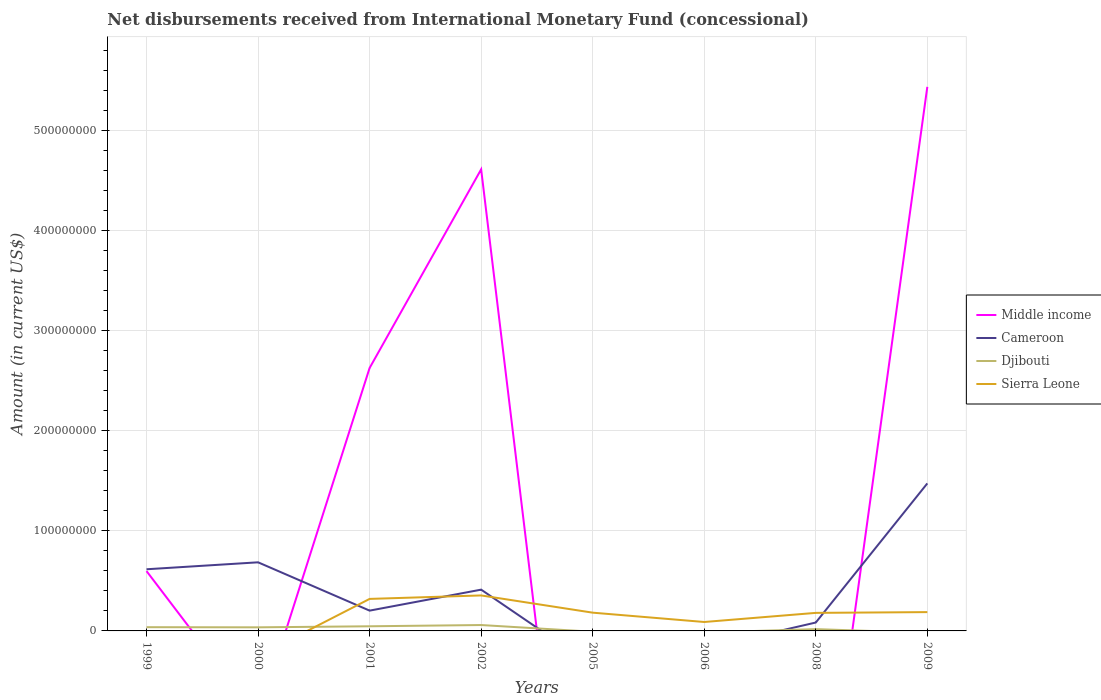How many different coloured lines are there?
Offer a terse response. 4. Does the line corresponding to Cameroon intersect with the line corresponding to Middle income?
Make the answer very short. Yes. Is the number of lines equal to the number of legend labels?
Ensure brevity in your answer.  No. What is the total amount of disbursements received from International Monetary Fund in Sierra Leone in the graph?
Provide a short and direct response. 2.17e+05. What is the difference between the highest and the second highest amount of disbursements received from International Monetary Fund in Middle income?
Give a very brief answer. 5.43e+08. What is the difference between the highest and the lowest amount of disbursements received from International Monetary Fund in Sierra Leone?
Make the answer very short. 5. Is the amount of disbursements received from International Monetary Fund in Cameroon strictly greater than the amount of disbursements received from International Monetary Fund in Djibouti over the years?
Your answer should be very brief. No. Are the values on the major ticks of Y-axis written in scientific E-notation?
Your answer should be compact. No. How many legend labels are there?
Your answer should be very brief. 4. How are the legend labels stacked?
Your response must be concise. Vertical. What is the title of the graph?
Your response must be concise. Net disbursements received from International Monetary Fund (concessional). Does "Cabo Verde" appear as one of the legend labels in the graph?
Your answer should be compact. No. What is the label or title of the Y-axis?
Your response must be concise. Amount (in current US$). What is the Amount (in current US$) of Middle income in 1999?
Keep it short and to the point. 5.98e+07. What is the Amount (in current US$) in Cameroon in 1999?
Offer a terse response. 6.16e+07. What is the Amount (in current US$) of Djibouti in 1999?
Your answer should be very brief. 3.73e+06. What is the Amount (in current US$) in Sierra Leone in 1999?
Your answer should be very brief. 0. What is the Amount (in current US$) in Middle income in 2000?
Give a very brief answer. 0. What is the Amount (in current US$) of Cameroon in 2000?
Offer a terse response. 6.85e+07. What is the Amount (in current US$) of Djibouti in 2000?
Offer a very short reply. 3.60e+06. What is the Amount (in current US$) of Sierra Leone in 2000?
Provide a succinct answer. 0. What is the Amount (in current US$) in Middle income in 2001?
Your response must be concise. 2.63e+08. What is the Amount (in current US$) of Cameroon in 2001?
Ensure brevity in your answer.  2.03e+07. What is the Amount (in current US$) of Djibouti in 2001?
Offer a terse response. 4.63e+06. What is the Amount (in current US$) in Sierra Leone in 2001?
Offer a very short reply. 3.20e+07. What is the Amount (in current US$) in Middle income in 2002?
Your answer should be compact. 4.61e+08. What is the Amount (in current US$) in Cameroon in 2002?
Ensure brevity in your answer.  4.12e+07. What is the Amount (in current US$) of Djibouti in 2002?
Make the answer very short. 5.88e+06. What is the Amount (in current US$) in Sierra Leone in 2002?
Provide a short and direct response. 3.54e+07. What is the Amount (in current US$) in Sierra Leone in 2005?
Give a very brief answer. 1.82e+07. What is the Amount (in current US$) in Middle income in 2006?
Offer a very short reply. 0. What is the Amount (in current US$) in Cameroon in 2006?
Ensure brevity in your answer.  0. What is the Amount (in current US$) in Djibouti in 2006?
Provide a short and direct response. 0. What is the Amount (in current US$) in Sierra Leone in 2006?
Make the answer very short. 8.92e+06. What is the Amount (in current US$) of Cameroon in 2008?
Provide a succinct answer. 8.38e+06. What is the Amount (in current US$) in Djibouti in 2008?
Offer a very short reply. 1.80e+06. What is the Amount (in current US$) of Sierra Leone in 2008?
Give a very brief answer. 1.80e+07. What is the Amount (in current US$) in Middle income in 2009?
Your response must be concise. 5.43e+08. What is the Amount (in current US$) of Cameroon in 2009?
Keep it short and to the point. 1.47e+08. What is the Amount (in current US$) of Djibouti in 2009?
Keep it short and to the point. 0. What is the Amount (in current US$) of Sierra Leone in 2009?
Offer a terse response. 1.88e+07. Across all years, what is the maximum Amount (in current US$) in Middle income?
Give a very brief answer. 5.43e+08. Across all years, what is the maximum Amount (in current US$) in Cameroon?
Ensure brevity in your answer.  1.47e+08. Across all years, what is the maximum Amount (in current US$) in Djibouti?
Make the answer very short. 5.88e+06. Across all years, what is the maximum Amount (in current US$) in Sierra Leone?
Your answer should be compact. 3.54e+07. What is the total Amount (in current US$) of Middle income in the graph?
Offer a very short reply. 1.33e+09. What is the total Amount (in current US$) in Cameroon in the graph?
Offer a terse response. 3.47e+08. What is the total Amount (in current US$) of Djibouti in the graph?
Your answer should be compact. 1.96e+07. What is the total Amount (in current US$) of Sierra Leone in the graph?
Keep it short and to the point. 1.31e+08. What is the difference between the Amount (in current US$) in Cameroon in 1999 and that in 2000?
Offer a terse response. -6.95e+06. What is the difference between the Amount (in current US$) of Djibouti in 1999 and that in 2000?
Offer a terse response. 1.32e+05. What is the difference between the Amount (in current US$) in Middle income in 1999 and that in 2001?
Offer a very short reply. -2.03e+08. What is the difference between the Amount (in current US$) in Cameroon in 1999 and that in 2001?
Ensure brevity in your answer.  4.13e+07. What is the difference between the Amount (in current US$) in Djibouti in 1999 and that in 2001?
Keep it short and to the point. -9.00e+05. What is the difference between the Amount (in current US$) of Middle income in 1999 and that in 2002?
Your answer should be very brief. -4.01e+08. What is the difference between the Amount (in current US$) of Cameroon in 1999 and that in 2002?
Make the answer very short. 2.03e+07. What is the difference between the Amount (in current US$) in Djibouti in 1999 and that in 2002?
Ensure brevity in your answer.  -2.16e+06. What is the difference between the Amount (in current US$) in Cameroon in 1999 and that in 2008?
Your answer should be compact. 5.32e+07. What is the difference between the Amount (in current US$) of Djibouti in 1999 and that in 2008?
Provide a short and direct response. 1.93e+06. What is the difference between the Amount (in current US$) of Middle income in 1999 and that in 2009?
Keep it short and to the point. -4.84e+08. What is the difference between the Amount (in current US$) in Cameroon in 1999 and that in 2009?
Provide a succinct answer. -8.58e+07. What is the difference between the Amount (in current US$) of Cameroon in 2000 and that in 2001?
Ensure brevity in your answer.  4.83e+07. What is the difference between the Amount (in current US$) in Djibouti in 2000 and that in 2001?
Your answer should be very brief. -1.03e+06. What is the difference between the Amount (in current US$) of Cameroon in 2000 and that in 2002?
Provide a short and direct response. 2.73e+07. What is the difference between the Amount (in current US$) in Djibouti in 2000 and that in 2002?
Give a very brief answer. -2.29e+06. What is the difference between the Amount (in current US$) of Cameroon in 2000 and that in 2008?
Provide a succinct answer. 6.01e+07. What is the difference between the Amount (in current US$) in Djibouti in 2000 and that in 2008?
Your answer should be compact. 1.80e+06. What is the difference between the Amount (in current US$) of Cameroon in 2000 and that in 2009?
Ensure brevity in your answer.  -7.88e+07. What is the difference between the Amount (in current US$) in Middle income in 2001 and that in 2002?
Ensure brevity in your answer.  -1.98e+08. What is the difference between the Amount (in current US$) of Cameroon in 2001 and that in 2002?
Your answer should be very brief. -2.10e+07. What is the difference between the Amount (in current US$) in Djibouti in 2001 and that in 2002?
Give a very brief answer. -1.26e+06. What is the difference between the Amount (in current US$) in Sierra Leone in 2001 and that in 2002?
Provide a succinct answer. -3.47e+06. What is the difference between the Amount (in current US$) of Sierra Leone in 2001 and that in 2005?
Give a very brief answer. 1.37e+07. What is the difference between the Amount (in current US$) in Sierra Leone in 2001 and that in 2006?
Offer a very short reply. 2.30e+07. What is the difference between the Amount (in current US$) in Cameroon in 2001 and that in 2008?
Offer a terse response. 1.19e+07. What is the difference between the Amount (in current US$) in Djibouti in 2001 and that in 2008?
Provide a short and direct response. 2.83e+06. What is the difference between the Amount (in current US$) of Sierra Leone in 2001 and that in 2008?
Your answer should be very brief. 1.39e+07. What is the difference between the Amount (in current US$) in Middle income in 2001 and that in 2009?
Offer a terse response. -2.81e+08. What is the difference between the Amount (in current US$) in Cameroon in 2001 and that in 2009?
Provide a succinct answer. -1.27e+08. What is the difference between the Amount (in current US$) in Sierra Leone in 2001 and that in 2009?
Offer a terse response. 1.32e+07. What is the difference between the Amount (in current US$) of Sierra Leone in 2002 and that in 2005?
Your answer should be very brief. 1.72e+07. What is the difference between the Amount (in current US$) in Sierra Leone in 2002 and that in 2006?
Make the answer very short. 2.65e+07. What is the difference between the Amount (in current US$) in Cameroon in 2002 and that in 2008?
Your answer should be very brief. 3.29e+07. What is the difference between the Amount (in current US$) in Djibouti in 2002 and that in 2008?
Keep it short and to the point. 4.08e+06. What is the difference between the Amount (in current US$) of Sierra Leone in 2002 and that in 2008?
Give a very brief answer. 1.74e+07. What is the difference between the Amount (in current US$) of Middle income in 2002 and that in 2009?
Your response must be concise. -8.24e+07. What is the difference between the Amount (in current US$) of Cameroon in 2002 and that in 2009?
Offer a terse response. -1.06e+08. What is the difference between the Amount (in current US$) in Sierra Leone in 2002 and that in 2009?
Give a very brief answer. 1.66e+07. What is the difference between the Amount (in current US$) of Sierra Leone in 2005 and that in 2006?
Give a very brief answer. 9.32e+06. What is the difference between the Amount (in current US$) of Sierra Leone in 2005 and that in 2008?
Your response must be concise. 2.17e+05. What is the difference between the Amount (in current US$) of Sierra Leone in 2005 and that in 2009?
Your answer should be very brief. -5.57e+05. What is the difference between the Amount (in current US$) in Sierra Leone in 2006 and that in 2008?
Offer a terse response. -9.10e+06. What is the difference between the Amount (in current US$) in Sierra Leone in 2006 and that in 2009?
Your answer should be very brief. -9.88e+06. What is the difference between the Amount (in current US$) of Cameroon in 2008 and that in 2009?
Offer a very short reply. -1.39e+08. What is the difference between the Amount (in current US$) in Sierra Leone in 2008 and that in 2009?
Your answer should be compact. -7.74e+05. What is the difference between the Amount (in current US$) of Middle income in 1999 and the Amount (in current US$) of Cameroon in 2000?
Ensure brevity in your answer.  -8.77e+06. What is the difference between the Amount (in current US$) of Middle income in 1999 and the Amount (in current US$) of Djibouti in 2000?
Offer a very short reply. 5.62e+07. What is the difference between the Amount (in current US$) in Cameroon in 1999 and the Amount (in current US$) in Djibouti in 2000?
Your answer should be very brief. 5.80e+07. What is the difference between the Amount (in current US$) of Middle income in 1999 and the Amount (in current US$) of Cameroon in 2001?
Provide a succinct answer. 3.95e+07. What is the difference between the Amount (in current US$) of Middle income in 1999 and the Amount (in current US$) of Djibouti in 2001?
Give a very brief answer. 5.51e+07. What is the difference between the Amount (in current US$) in Middle income in 1999 and the Amount (in current US$) in Sierra Leone in 2001?
Make the answer very short. 2.78e+07. What is the difference between the Amount (in current US$) in Cameroon in 1999 and the Amount (in current US$) in Djibouti in 2001?
Make the answer very short. 5.69e+07. What is the difference between the Amount (in current US$) in Cameroon in 1999 and the Amount (in current US$) in Sierra Leone in 2001?
Make the answer very short. 2.96e+07. What is the difference between the Amount (in current US$) of Djibouti in 1999 and the Amount (in current US$) of Sierra Leone in 2001?
Offer a terse response. -2.82e+07. What is the difference between the Amount (in current US$) of Middle income in 1999 and the Amount (in current US$) of Cameroon in 2002?
Give a very brief answer. 1.85e+07. What is the difference between the Amount (in current US$) in Middle income in 1999 and the Amount (in current US$) in Djibouti in 2002?
Keep it short and to the point. 5.39e+07. What is the difference between the Amount (in current US$) in Middle income in 1999 and the Amount (in current US$) in Sierra Leone in 2002?
Keep it short and to the point. 2.43e+07. What is the difference between the Amount (in current US$) in Cameroon in 1999 and the Amount (in current US$) in Djibouti in 2002?
Your answer should be compact. 5.57e+07. What is the difference between the Amount (in current US$) in Cameroon in 1999 and the Amount (in current US$) in Sierra Leone in 2002?
Your answer should be very brief. 2.61e+07. What is the difference between the Amount (in current US$) in Djibouti in 1999 and the Amount (in current US$) in Sierra Leone in 2002?
Your answer should be compact. -3.17e+07. What is the difference between the Amount (in current US$) in Middle income in 1999 and the Amount (in current US$) in Sierra Leone in 2005?
Provide a short and direct response. 4.15e+07. What is the difference between the Amount (in current US$) of Cameroon in 1999 and the Amount (in current US$) of Sierra Leone in 2005?
Provide a succinct answer. 4.33e+07. What is the difference between the Amount (in current US$) of Djibouti in 1999 and the Amount (in current US$) of Sierra Leone in 2005?
Provide a short and direct response. -1.45e+07. What is the difference between the Amount (in current US$) in Middle income in 1999 and the Amount (in current US$) in Sierra Leone in 2006?
Offer a very short reply. 5.08e+07. What is the difference between the Amount (in current US$) of Cameroon in 1999 and the Amount (in current US$) of Sierra Leone in 2006?
Ensure brevity in your answer.  5.27e+07. What is the difference between the Amount (in current US$) of Djibouti in 1999 and the Amount (in current US$) of Sierra Leone in 2006?
Provide a succinct answer. -5.19e+06. What is the difference between the Amount (in current US$) in Middle income in 1999 and the Amount (in current US$) in Cameroon in 2008?
Offer a terse response. 5.14e+07. What is the difference between the Amount (in current US$) in Middle income in 1999 and the Amount (in current US$) in Djibouti in 2008?
Ensure brevity in your answer.  5.80e+07. What is the difference between the Amount (in current US$) in Middle income in 1999 and the Amount (in current US$) in Sierra Leone in 2008?
Your answer should be compact. 4.17e+07. What is the difference between the Amount (in current US$) of Cameroon in 1999 and the Amount (in current US$) of Djibouti in 2008?
Keep it short and to the point. 5.98e+07. What is the difference between the Amount (in current US$) in Cameroon in 1999 and the Amount (in current US$) in Sierra Leone in 2008?
Offer a very short reply. 4.36e+07. What is the difference between the Amount (in current US$) in Djibouti in 1999 and the Amount (in current US$) in Sierra Leone in 2008?
Provide a succinct answer. -1.43e+07. What is the difference between the Amount (in current US$) of Middle income in 1999 and the Amount (in current US$) of Cameroon in 2009?
Keep it short and to the point. -8.76e+07. What is the difference between the Amount (in current US$) in Middle income in 1999 and the Amount (in current US$) in Sierra Leone in 2009?
Provide a succinct answer. 4.10e+07. What is the difference between the Amount (in current US$) in Cameroon in 1999 and the Amount (in current US$) in Sierra Leone in 2009?
Give a very brief answer. 4.28e+07. What is the difference between the Amount (in current US$) of Djibouti in 1999 and the Amount (in current US$) of Sierra Leone in 2009?
Your answer should be compact. -1.51e+07. What is the difference between the Amount (in current US$) in Cameroon in 2000 and the Amount (in current US$) in Djibouti in 2001?
Your response must be concise. 6.39e+07. What is the difference between the Amount (in current US$) in Cameroon in 2000 and the Amount (in current US$) in Sierra Leone in 2001?
Provide a short and direct response. 3.66e+07. What is the difference between the Amount (in current US$) of Djibouti in 2000 and the Amount (in current US$) of Sierra Leone in 2001?
Provide a short and direct response. -2.84e+07. What is the difference between the Amount (in current US$) of Cameroon in 2000 and the Amount (in current US$) of Djibouti in 2002?
Offer a very short reply. 6.26e+07. What is the difference between the Amount (in current US$) of Cameroon in 2000 and the Amount (in current US$) of Sierra Leone in 2002?
Make the answer very short. 3.31e+07. What is the difference between the Amount (in current US$) of Djibouti in 2000 and the Amount (in current US$) of Sierra Leone in 2002?
Give a very brief answer. -3.18e+07. What is the difference between the Amount (in current US$) in Cameroon in 2000 and the Amount (in current US$) in Sierra Leone in 2005?
Your response must be concise. 5.03e+07. What is the difference between the Amount (in current US$) in Djibouti in 2000 and the Amount (in current US$) in Sierra Leone in 2005?
Provide a short and direct response. -1.46e+07. What is the difference between the Amount (in current US$) of Cameroon in 2000 and the Amount (in current US$) of Sierra Leone in 2006?
Offer a terse response. 5.96e+07. What is the difference between the Amount (in current US$) of Djibouti in 2000 and the Amount (in current US$) of Sierra Leone in 2006?
Your response must be concise. -5.32e+06. What is the difference between the Amount (in current US$) of Cameroon in 2000 and the Amount (in current US$) of Djibouti in 2008?
Give a very brief answer. 6.67e+07. What is the difference between the Amount (in current US$) in Cameroon in 2000 and the Amount (in current US$) in Sierra Leone in 2008?
Ensure brevity in your answer.  5.05e+07. What is the difference between the Amount (in current US$) of Djibouti in 2000 and the Amount (in current US$) of Sierra Leone in 2008?
Your answer should be very brief. -1.44e+07. What is the difference between the Amount (in current US$) of Cameroon in 2000 and the Amount (in current US$) of Sierra Leone in 2009?
Provide a short and direct response. 4.97e+07. What is the difference between the Amount (in current US$) of Djibouti in 2000 and the Amount (in current US$) of Sierra Leone in 2009?
Your response must be concise. -1.52e+07. What is the difference between the Amount (in current US$) of Middle income in 2001 and the Amount (in current US$) of Cameroon in 2002?
Provide a short and direct response. 2.21e+08. What is the difference between the Amount (in current US$) of Middle income in 2001 and the Amount (in current US$) of Djibouti in 2002?
Your answer should be compact. 2.57e+08. What is the difference between the Amount (in current US$) in Middle income in 2001 and the Amount (in current US$) in Sierra Leone in 2002?
Provide a short and direct response. 2.27e+08. What is the difference between the Amount (in current US$) of Cameroon in 2001 and the Amount (in current US$) of Djibouti in 2002?
Provide a short and direct response. 1.44e+07. What is the difference between the Amount (in current US$) of Cameroon in 2001 and the Amount (in current US$) of Sierra Leone in 2002?
Your response must be concise. -1.52e+07. What is the difference between the Amount (in current US$) in Djibouti in 2001 and the Amount (in current US$) in Sierra Leone in 2002?
Ensure brevity in your answer.  -3.08e+07. What is the difference between the Amount (in current US$) of Middle income in 2001 and the Amount (in current US$) of Sierra Leone in 2005?
Your response must be concise. 2.44e+08. What is the difference between the Amount (in current US$) of Cameroon in 2001 and the Amount (in current US$) of Sierra Leone in 2005?
Keep it short and to the point. 2.03e+06. What is the difference between the Amount (in current US$) in Djibouti in 2001 and the Amount (in current US$) in Sierra Leone in 2005?
Ensure brevity in your answer.  -1.36e+07. What is the difference between the Amount (in current US$) of Middle income in 2001 and the Amount (in current US$) of Sierra Leone in 2006?
Ensure brevity in your answer.  2.54e+08. What is the difference between the Amount (in current US$) in Cameroon in 2001 and the Amount (in current US$) in Sierra Leone in 2006?
Your response must be concise. 1.13e+07. What is the difference between the Amount (in current US$) in Djibouti in 2001 and the Amount (in current US$) in Sierra Leone in 2006?
Your response must be concise. -4.29e+06. What is the difference between the Amount (in current US$) in Middle income in 2001 and the Amount (in current US$) in Cameroon in 2008?
Provide a succinct answer. 2.54e+08. What is the difference between the Amount (in current US$) in Middle income in 2001 and the Amount (in current US$) in Djibouti in 2008?
Your answer should be very brief. 2.61e+08. What is the difference between the Amount (in current US$) of Middle income in 2001 and the Amount (in current US$) of Sierra Leone in 2008?
Your answer should be compact. 2.45e+08. What is the difference between the Amount (in current US$) in Cameroon in 2001 and the Amount (in current US$) in Djibouti in 2008?
Your answer should be compact. 1.85e+07. What is the difference between the Amount (in current US$) in Cameroon in 2001 and the Amount (in current US$) in Sierra Leone in 2008?
Your response must be concise. 2.25e+06. What is the difference between the Amount (in current US$) of Djibouti in 2001 and the Amount (in current US$) of Sierra Leone in 2008?
Provide a short and direct response. -1.34e+07. What is the difference between the Amount (in current US$) in Middle income in 2001 and the Amount (in current US$) in Cameroon in 2009?
Your answer should be very brief. 1.15e+08. What is the difference between the Amount (in current US$) in Middle income in 2001 and the Amount (in current US$) in Sierra Leone in 2009?
Offer a very short reply. 2.44e+08. What is the difference between the Amount (in current US$) in Cameroon in 2001 and the Amount (in current US$) in Sierra Leone in 2009?
Your answer should be very brief. 1.47e+06. What is the difference between the Amount (in current US$) in Djibouti in 2001 and the Amount (in current US$) in Sierra Leone in 2009?
Provide a succinct answer. -1.42e+07. What is the difference between the Amount (in current US$) of Middle income in 2002 and the Amount (in current US$) of Sierra Leone in 2005?
Give a very brief answer. 4.43e+08. What is the difference between the Amount (in current US$) in Cameroon in 2002 and the Amount (in current US$) in Sierra Leone in 2005?
Keep it short and to the point. 2.30e+07. What is the difference between the Amount (in current US$) in Djibouti in 2002 and the Amount (in current US$) in Sierra Leone in 2005?
Your response must be concise. -1.24e+07. What is the difference between the Amount (in current US$) in Middle income in 2002 and the Amount (in current US$) in Sierra Leone in 2006?
Your answer should be very brief. 4.52e+08. What is the difference between the Amount (in current US$) of Cameroon in 2002 and the Amount (in current US$) of Sierra Leone in 2006?
Ensure brevity in your answer.  3.23e+07. What is the difference between the Amount (in current US$) of Djibouti in 2002 and the Amount (in current US$) of Sierra Leone in 2006?
Offer a terse response. -3.04e+06. What is the difference between the Amount (in current US$) of Middle income in 2002 and the Amount (in current US$) of Cameroon in 2008?
Give a very brief answer. 4.53e+08. What is the difference between the Amount (in current US$) in Middle income in 2002 and the Amount (in current US$) in Djibouti in 2008?
Offer a terse response. 4.59e+08. What is the difference between the Amount (in current US$) in Middle income in 2002 and the Amount (in current US$) in Sierra Leone in 2008?
Your response must be concise. 4.43e+08. What is the difference between the Amount (in current US$) of Cameroon in 2002 and the Amount (in current US$) of Djibouti in 2008?
Give a very brief answer. 3.94e+07. What is the difference between the Amount (in current US$) of Cameroon in 2002 and the Amount (in current US$) of Sierra Leone in 2008?
Your answer should be compact. 2.32e+07. What is the difference between the Amount (in current US$) in Djibouti in 2002 and the Amount (in current US$) in Sierra Leone in 2008?
Keep it short and to the point. -1.21e+07. What is the difference between the Amount (in current US$) of Middle income in 2002 and the Amount (in current US$) of Cameroon in 2009?
Your answer should be compact. 3.14e+08. What is the difference between the Amount (in current US$) of Middle income in 2002 and the Amount (in current US$) of Sierra Leone in 2009?
Ensure brevity in your answer.  4.42e+08. What is the difference between the Amount (in current US$) in Cameroon in 2002 and the Amount (in current US$) in Sierra Leone in 2009?
Keep it short and to the point. 2.24e+07. What is the difference between the Amount (in current US$) in Djibouti in 2002 and the Amount (in current US$) in Sierra Leone in 2009?
Provide a succinct answer. -1.29e+07. What is the difference between the Amount (in current US$) in Cameroon in 2008 and the Amount (in current US$) in Sierra Leone in 2009?
Your answer should be compact. -1.04e+07. What is the difference between the Amount (in current US$) in Djibouti in 2008 and the Amount (in current US$) in Sierra Leone in 2009?
Ensure brevity in your answer.  -1.70e+07. What is the average Amount (in current US$) in Middle income per year?
Your response must be concise. 1.66e+08. What is the average Amount (in current US$) in Cameroon per year?
Offer a terse response. 4.34e+07. What is the average Amount (in current US$) in Djibouti per year?
Your answer should be compact. 2.45e+06. What is the average Amount (in current US$) of Sierra Leone per year?
Keep it short and to the point. 1.64e+07. In the year 1999, what is the difference between the Amount (in current US$) of Middle income and Amount (in current US$) of Cameroon?
Provide a succinct answer. -1.82e+06. In the year 1999, what is the difference between the Amount (in current US$) in Middle income and Amount (in current US$) in Djibouti?
Offer a very short reply. 5.60e+07. In the year 1999, what is the difference between the Amount (in current US$) of Cameroon and Amount (in current US$) of Djibouti?
Your response must be concise. 5.78e+07. In the year 2000, what is the difference between the Amount (in current US$) of Cameroon and Amount (in current US$) of Djibouti?
Provide a short and direct response. 6.49e+07. In the year 2001, what is the difference between the Amount (in current US$) of Middle income and Amount (in current US$) of Cameroon?
Provide a succinct answer. 2.42e+08. In the year 2001, what is the difference between the Amount (in current US$) in Middle income and Amount (in current US$) in Djibouti?
Ensure brevity in your answer.  2.58e+08. In the year 2001, what is the difference between the Amount (in current US$) in Middle income and Amount (in current US$) in Sierra Leone?
Give a very brief answer. 2.31e+08. In the year 2001, what is the difference between the Amount (in current US$) in Cameroon and Amount (in current US$) in Djibouti?
Your answer should be compact. 1.56e+07. In the year 2001, what is the difference between the Amount (in current US$) of Cameroon and Amount (in current US$) of Sierra Leone?
Provide a short and direct response. -1.17e+07. In the year 2001, what is the difference between the Amount (in current US$) of Djibouti and Amount (in current US$) of Sierra Leone?
Offer a terse response. -2.73e+07. In the year 2002, what is the difference between the Amount (in current US$) in Middle income and Amount (in current US$) in Cameroon?
Ensure brevity in your answer.  4.20e+08. In the year 2002, what is the difference between the Amount (in current US$) in Middle income and Amount (in current US$) in Djibouti?
Offer a very short reply. 4.55e+08. In the year 2002, what is the difference between the Amount (in current US$) of Middle income and Amount (in current US$) of Sierra Leone?
Give a very brief answer. 4.26e+08. In the year 2002, what is the difference between the Amount (in current US$) of Cameroon and Amount (in current US$) of Djibouti?
Ensure brevity in your answer.  3.53e+07. In the year 2002, what is the difference between the Amount (in current US$) of Cameroon and Amount (in current US$) of Sierra Leone?
Ensure brevity in your answer.  5.79e+06. In the year 2002, what is the difference between the Amount (in current US$) in Djibouti and Amount (in current US$) in Sierra Leone?
Offer a very short reply. -2.96e+07. In the year 2008, what is the difference between the Amount (in current US$) in Cameroon and Amount (in current US$) in Djibouti?
Your response must be concise. 6.58e+06. In the year 2008, what is the difference between the Amount (in current US$) in Cameroon and Amount (in current US$) in Sierra Leone?
Your answer should be compact. -9.64e+06. In the year 2008, what is the difference between the Amount (in current US$) of Djibouti and Amount (in current US$) of Sierra Leone?
Your answer should be compact. -1.62e+07. In the year 2009, what is the difference between the Amount (in current US$) in Middle income and Amount (in current US$) in Cameroon?
Give a very brief answer. 3.96e+08. In the year 2009, what is the difference between the Amount (in current US$) in Middle income and Amount (in current US$) in Sierra Leone?
Give a very brief answer. 5.25e+08. In the year 2009, what is the difference between the Amount (in current US$) in Cameroon and Amount (in current US$) in Sierra Leone?
Offer a terse response. 1.29e+08. What is the ratio of the Amount (in current US$) of Cameroon in 1999 to that in 2000?
Offer a very short reply. 0.9. What is the ratio of the Amount (in current US$) in Djibouti in 1999 to that in 2000?
Keep it short and to the point. 1.04. What is the ratio of the Amount (in current US$) of Middle income in 1999 to that in 2001?
Keep it short and to the point. 0.23. What is the ratio of the Amount (in current US$) in Cameroon in 1999 to that in 2001?
Offer a very short reply. 3.04. What is the ratio of the Amount (in current US$) in Djibouti in 1999 to that in 2001?
Your response must be concise. 0.81. What is the ratio of the Amount (in current US$) of Middle income in 1999 to that in 2002?
Offer a terse response. 0.13. What is the ratio of the Amount (in current US$) of Cameroon in 1999 to that in 2002?
Offer a very short reply. 1.49. What is the ratio of the Amount (in current US$) of Djibouti in 1999 to that in 2002?
Provide a succinct answer. 0.63. What is the ratio of the Amount (in current US$) of Cameroon in 1999 to that in 2008?
Provide a short and direct response. 7.35. What is the ratio of the Amount (in current US$) in Djibouti in 1999 to that in 2008?
Give a very brief answer. 2.07. What is the ratio of the Amount (in current US$) in Middle income in 1999 to that in 2009?
Offer a very short reply. 0.11. What is the ratio of the Amount (in current US$) of Cameroon in 1999 to that in 2009?
Make the answer very short. 0.42. What is the ratio of the Amount (in current US$) of Cameroon in 2000 to that in 2001?
Your answer should be very brief. 3.38. What is the ratio of the Amount (in current US$) in Djibouti in 2000 to that in 2001?
Provide a succinct answer. 0.78. What is the ratio of the Amount (in current US$) in Cameroon in 2000 to that in 2002?
Give a very brief answer. 1.66. What is the ratio of the Amount (in current US$) of Djibouti in 2000 to that in 2002?
Offer a very short reply. 0.61. What is the ratio of the Amount (in current US$) of Cameroon in 2000 to that in 2008?
Offer a very short reply. 8.18. What is the ratio of the Amount (in current US$) in Djibouti in 2000 to that in 2008?
Your answer should be very brief. 2. What is the ratio of the Amount (in current US$) in Cameroon in 2000 to that in 2009?
Provide a succinct answer. 0.47. What is the ratio of the Amount (in current US$) in Middle income in 2001 to that in 2002?
Your response must be concise. 0.57. What is the ratio of the Amount (in current US$) in Cameroon in 2001 to that in 2002?
Offer a terse response. 0.49. What is the ratio of the Amount (in current US$) of Djibouti in 2001 to that in 2002?
Provide a short and direct response. 0.79. What is the ratio of the Amount (in current US$) in Sierra Leone in 2001 to that in 2002?
Provide a short and direct response. 0.9. What is the ratio of the Amount (in current US$) in Sierra Leone in 2001 to that in 2005?
Your response must be concise. 1.75. What is the ratio of the Amount (in current US$) of Sierra Leone in 2001 to that in 2006?
Keep it short and to the point. 3.58. What is the ratio of the Amount (in current US$) in Cameroon in 2001 to that in 2008?
Keep it short and to the point. 2.42. What is the ratio of the Amount (in current US$) in Djibouti in 2001 to that in 2008?
Your answer should be compact. 2.57. What is the ratio of the Amount (in current US$) of Sierra Leone in 2001 to that in 2008?
Make the answer very short. 1.77. What is the ratio of the Amount (in current US$) of Middle income in 2001 to that in 2009?
Ensure brevity in your answer.  0.48. What is the ratio of the Amount (in current US$) in Cameroon in 2001 to that in 2009?
Your answer should be very brief. 0.14. What is the ratio of the Amount (in current US$) in Sierra Leone in 2001 to that in 2009?
Offer a terse response. 1.7. What is the ratio of the Amount (in current US$) of Sierra Leone in 2002 to that in 2005?
Give a very brief answer. 1.94. What is the ratio of the Amount (in current US$) in Sierra Leone in 2002 to that in 2006?
Your response must be concise. 3.97. What is the ratio of the Amount (in current US$) in Cameroon in 2002 to that in 2008?
Provide a succinct answer. 4.92. What is the ratio of the Amount (in current US$) in Djibouti in 2002 to that in 2008?
Ensure brevity in your answer.  3.27. What is the ratio of the Amount (in current US$) in Sierra Leone in 2002 to that in 2008?
Give a very brief answer. 1.97. What is the ratio of the Amount (in current US$) of Middle income in 2002 to that in 2009?
Your response must be concise. 0.85. What is the ratio of the Amount (in current US$) in Cameroon in 2002 to that in 2009?
Provide a short and direct response. 0.28. What is the ratio of the Amount (in current US$) of Sierra Leone in 2002 to that in 2009?
Offer a very short reply. 1.89. What is the ratio of the Amount (in current US$) of Sierra Leone in 2005 to that in 2006?
Provide a short and direct response. 2.04. What is the ratio of the Amount (in current US$) in Sierra Leone in 2005 to that in 2009?
Ensure brevity in your answer.  0.97. What is the ratio of the Amount (in current US$) in Sierra Leone in 2006 to that in 2008?
Your answer should be compact. 0.49. What is the ratio of the Amount (in current US$) of Sierra Leone in 2006 to that in 2009?
Give a very brief answer. 0.47. What is the ratio of the Amount (in current US$) in Cameroon in 2008 to that in 2009?
Your answer should be very brief. 0.06. What is the ratio of the Amount (in current US$) of Sierra Leone in 2008 to that in 2009?
Make the answer very short. 0.96. What is the difference between the highest and the second highest Amount (in current US$) in Middle income?
Provide a succinct answer. 8.24e+07. What is the difference between the highest and the second highest Amount (in current US$) in Cameroon?
Offer a very short reply. 7.88e+07. What is the difference between the highest and the second highest Amount (in current US$) of Djibouti?
Make the answer very short. 1.26e+06. What is the difference between the highest and the second highest Amount (in current US$) in Sierra Leone?
Make the answer very short. 3.47e+06. What is the difference between the highest and the lowest Amount (in current US$) in Middle income?
Make the answer very short. 5.43e+08. What is the difference between the highest and the lowest Amount (in current US$) of Cameroon?
Provide a succinct answer. 1.47e+08. What is the difference between the highest and the lowest Amount (in current US$) in Djibouti?
Your answer should be compact. 5.88e+06. What is the difference between the highest and the lowest Amount (in current US$) of Sierra Leone?
Keep it short and to the point. 3.54e+07. 